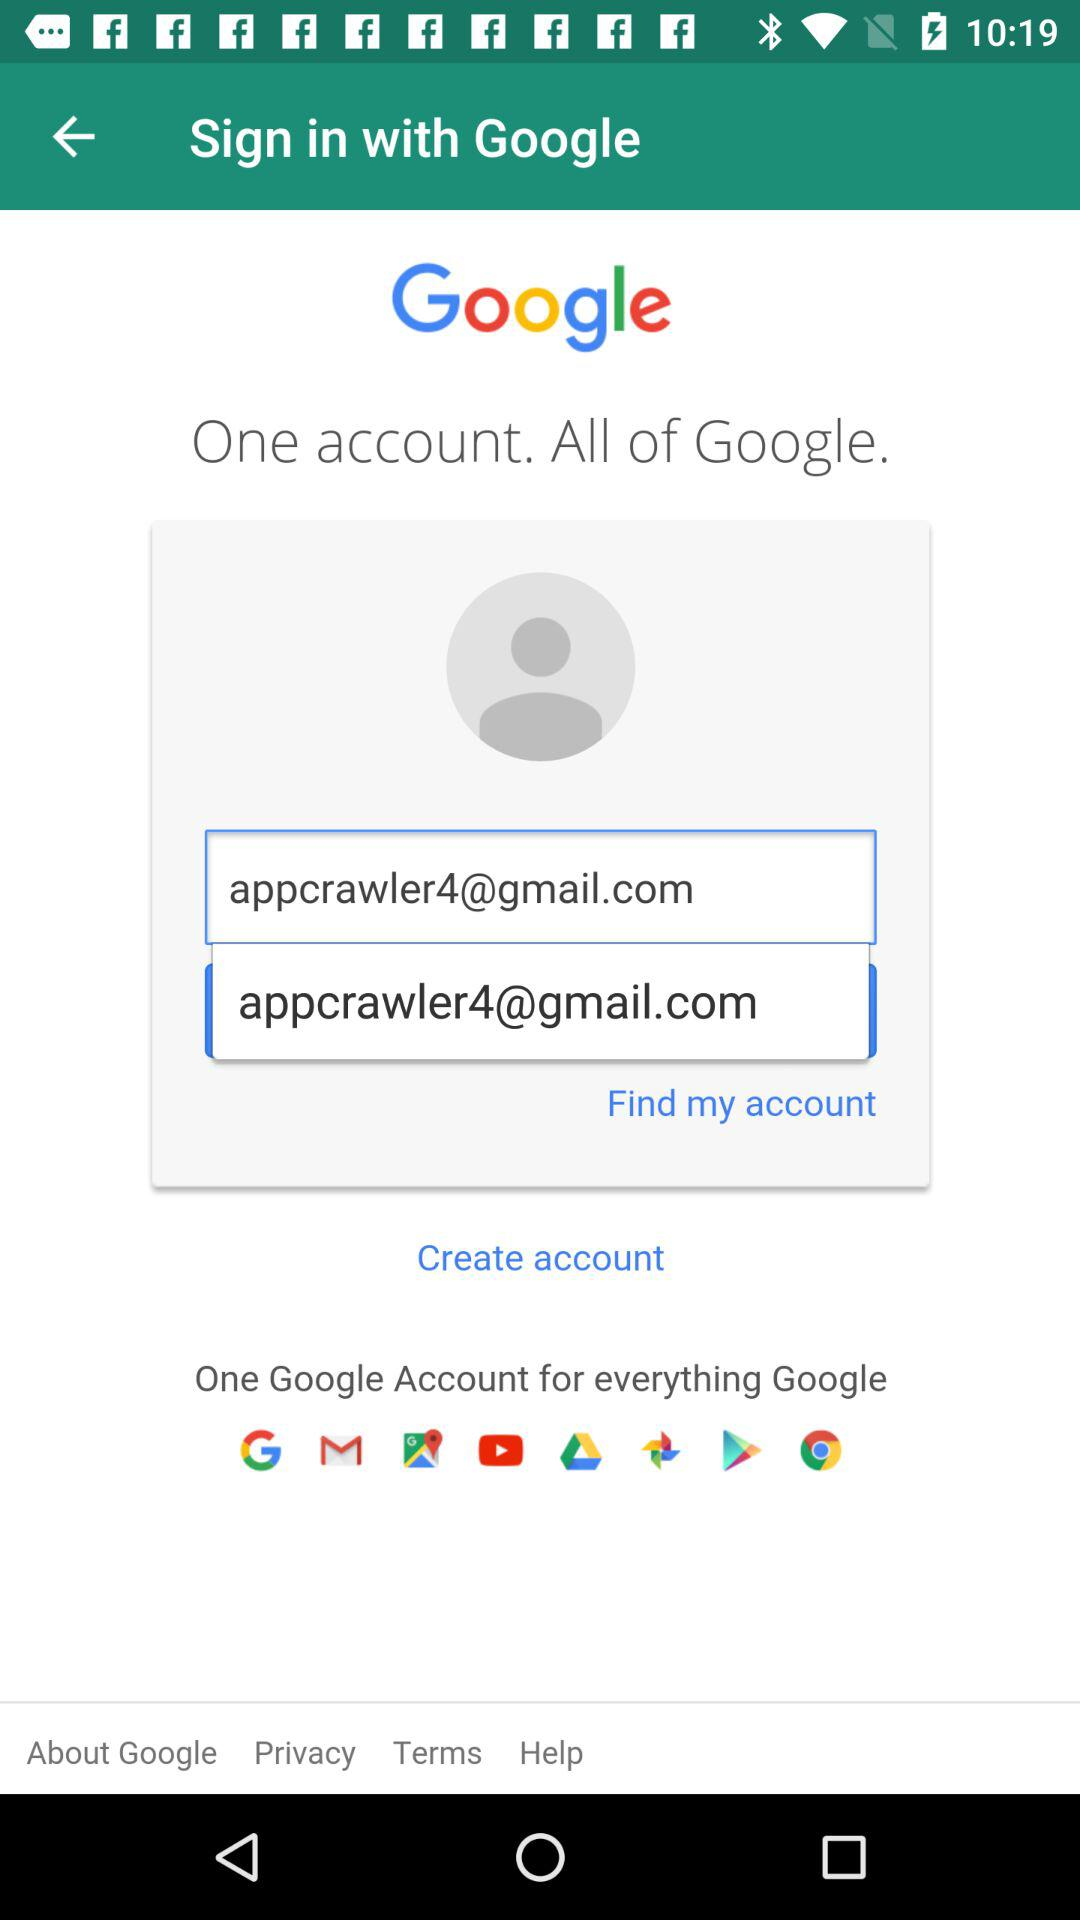Through what application can we sign in? You can sign in through "Google". 